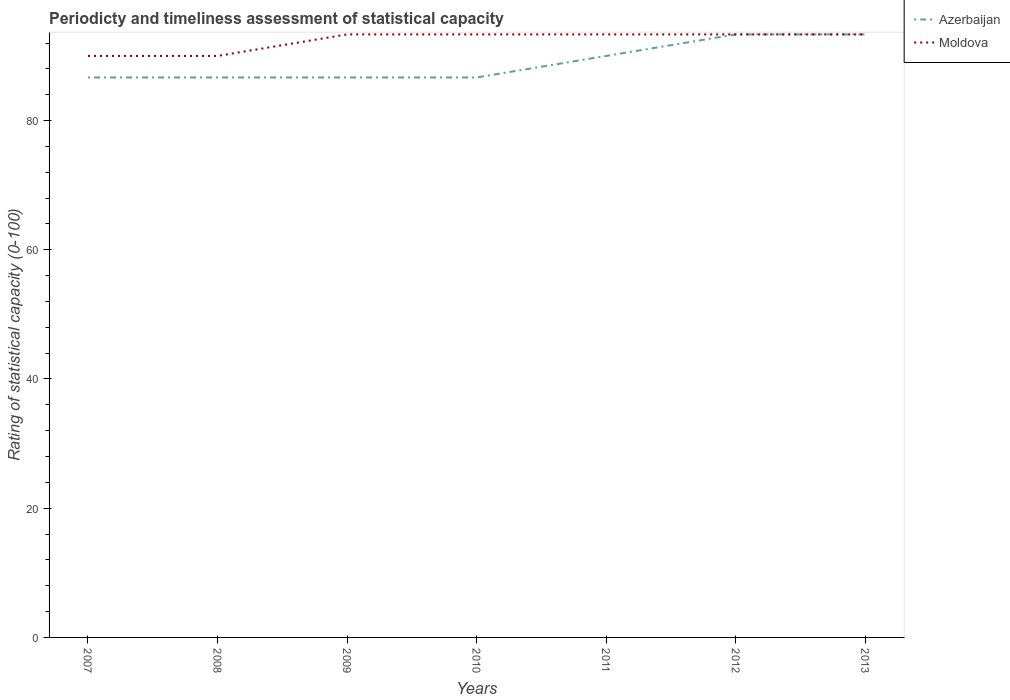Across all years, what is the maximum rating of statistical capacity in Azerbaijan?
Offer a very short reply. 86.67. In which year was the rating of statistical capacity in Azerbaijan maximum?
Ensure brevity in your answer.  2007. What is the total rating of statistical capacity in Moldova in the graph?
Offer a terse response. -3.33. What is the difference between the highest and the second highest rating of statistical capacity in Azerbaijan?
Offer a terse response. 6.67. How many lines are there?
Offer a terse response. 2. How many years are there in the graph?
Your answer should be very brief. 7. Are the values on the major ticks of Y-axis written in scientific E-notation?
Keep it short and to the point. No. Does the graph contain any zero values?
Keep it short and to the point. No. Where does the legend appear in the graph?
Provide a succinct answer. Top right. How many legend labels are there?
Ensure brevity in your answer.  2. What is the title of the graph?
Provide a succinct answer. Periodicty and timeliness assessment of statistical capacity. Does "Grenada" appear as one of the legend labels in the graph?
Give a very brief answer. No. What is the label or title of the Y-axis?
Ensure brevity in your answer.  Rating of statistical capacity (0-100). What is the Rating of statistical capacity (0-100) of Azerbaijan in 2007?
Offer a very short reply. 86.67. What is the Rating of statistical capacity (0-100) of Moldova in 2007?
Offer a terse response. 90. What is the Rating of statistical capacity (0-100) of Azerbaijan in 2008?
Offer a terse response. 86.67. What is the Rating of statistical capacity (0-100) of Azerbaijan in 2009?
Make the answer very short. 86.67. What is the Rating of statistical capacity (0-100) in Moldova in 2009?
Provide a succinct answer. 93.33. What is the Rating of statistical capacity (0-100) in Azerbaijan in 2010?
Offer a terse response. 86.67. What is the Rating of statistical capacity (0-100) of Moldova in 2010?
Ensure brevity in your answer.  93.33. What is the Rating of statistical capacity (0-100) of Azerbaijan in 2011?
Provide a short and direct response. 90. What is the Rating of statistical capacity (0-100) of Moldova in 2011?
Give a very brief answer. 93.33. What is the Rating of statistical capacity (0-100) in Azerbaijan in 2012?
Offer a terse response. 93.33. What is the Rating of statistical capacity (0-100) of Moldova in 2012?
Your answer should be very brief. 93.33. What is the Rating of statistical capacity (0-100) in Azerbaijan in 2013?
Offer a terse response. 93.33. What is the Rating of statistical capacity (0-100) in Moldova in 2013?
Ensure brevity in your answer.  93.33. Across all years, what is the maximum Rating of statistical capacity (0-100) of Azerbaijan?
Give a very brief answer. 93.33. Across all years, what is the maximum Rating of statistical capacity (0-100) of Moldova?
Your response must be concise. 93.33. Across all years, what is the minimum Rating of statistical capacity (0-100) in Azerbaijan?
Offer a very short reply. 86.67. What is the total Rating of statistical capacity (0-100) in Azerbaijan in the graph?
Give a very brief answer. 623.33. What is the total Rating of statistical capacity (0-100) in Moldova in the graph?
Make the answer very short. 646.67. What is the difference between the Rating of statistical capacity (0-100) of Azerbaijan in 2007 and that in 2011?
Provide a succinct answer. -3.33. What is the difference between the Rating of statistical capacity (0-100) of Moldova in 2007 and that in 2011?
Offer a terse response. -3.33. What is the difference between the Rating of statistical capacity (0-100) of Azerbaijan in 2007 and that in 2012?
Make the answer very short. -6.67. What is the difference between the Rating of statistical capacity (0-100) of Moldova in 2007 and that in 2012?
Give a very brief answer. -3.33. What is the difference between the Rating of statistical capacity (0-100) in Azerbaijan in 2007 and that in 2013?
Offer a very short reply. -6.67. What is the difference between the Rating of statistical capacity (0-100) of Moldova in 2007 and that in 2013?
Provide a short and direct response. -3.33. What is the difference between the Rating of statistical capacity (0-100) in Moldova in 2008 and that in 2009?
Your answer should be compact. -3.33. What is the difference between the Rating of statistical capacity (0-100) of Moldova in 2008 and that in 2011?
Offer a terse response. -3.33. What is the difference between the Rating of statistical capacity (0-100) of Azerbaijan in 2008 and that in 2012?
Your answer should be very brief. -6.67. What is the difference between the Rating of statistical capacity (0-100) in Moldova in 2008 and that in 2012?
Offer a very short reply. -3.33. What is the difference between the Rating of statistical capacity (0-100) of Azerbaijan in 2008 and that in 2013?
Ensure brevity in your answer.  -6.67. What is the difference between the Rating of statistical capacity (0-100) of Azerbaijan in 2009 and that in 2010?
Provide a short and direct response. 0. What is the difference between the Rating of statistical capacity (0-100) of Azerbaijan in 2009 and that in 2012?
Provide a succinct answer. -6.67. What is the difference between the Rating of statistical capacity (0-100) in Azerbaijan in 2009 and that in 2013?
Give a very brief answer. -6.67. What is the difference between the Rating of statistical capacity (0-100) of Azerbaijan in 2010 and that in 2012?
Offer a terse response. -6.67. What is the difference between the Rating of statistical capacity (0-100) of Moldova in 2010 and that in 2012?
Your answer should be very brief. 0. What is the difference between the Rating of statistical capacity (0-100) of Azerbaijan in 2010 and that in 2013?
Your response must be concise. -6.67. What is the difference between the Rating of statistical capacity (0-100) in Azerbaijan in 2011 and that in 2012?
Keep it short and to the point. -3.33. What is the difference between the Rating of statistical capacity (0-100) in Moldova in 2011 and that in 2013?
Your answer should be very brief. -0. What is the difference between the Rating of statistical capacity (0-100) in Moldova in 2012 and that in 2013?
Your answer should be compact. -0. What is the difference between the Rating of statistical capacity (0-100) in Azerbaijan in 2007 and the Rating of statistical capacity (0-100) in Moldova in 2009?
Your response must be concise. -6.67. What is the difference between the Rating of statistical capacity (0-100) in Azerbaijan in 2007 and the Rating of statistical capacity (0-100) in Moldova in 2010?
Provide a short and direct response. -6.67. What is the difference between the Rating of statistical capacity (0-100) in Azerbaijan in 2007 and the Rating of statistical capacity (0-100) in Moldova in 2011?
Keep it short and to the point. -6.67. What is the difference between the Rating of statistical capacity (0-100) in Azerbaijan in 2007 and the Rating of statistical capacity (0-100) in Moldova in 2012?
Provide a short and direct response. -6.67. What is the difference between the Rating of statistical capacity (0-100) of Azerbaijan in 2007 and the Rating of statistical capacity (0-100) of Moldova in 2013?
Provide a succinct answer. -6.67. What is the difference between the Rating of statistical capacity (0-100) of Azerbaijan in 2008 and the Rating of statistical capacity (0-100) of Moldova in 2009?
Provide a short and direct response. -6.67. What is the difference between the Rating of statistical capacity (0-100) of Azerbaijan in 2008 and the Rating of statistical capacity (0-100) of Moldova in 2010?
Your response must be concise. -6.67. What is the difference between the Rating of statistical capacity (0-100) of Azerbaijan in 2008 and the Rating of statistical capacity (0-100) of Moldova in 2011?
Your answer should be compact. -6.67. What is the difference between the Rating of statistical capacity (0-100) of Azerbaijan in 2008 and the Rating of statistical capacity (0-100) of Moldova in 2012?
Offer a terse response. -6.67. What is the difference between the Rating of statistical capacity (0-100) of Azerbaijan in 2008 and the Rating of statistical capacity (0-100) of Moldova in 2013?
Provide a short and direct response. -6.67. What is the difference between the Rating of statistical capacity (0-100) in Azerbaijan in 2009 and the Rating of statistical capacity (0-100) in Moldova in 2010?
Keep it short and to the point. -6.67. What is the difference between the Rating of statistical capacity (0-100) in Azerbaijan in 2009 and the Rating of statistical capacity (0-100) in Moldova in 2011?
Make the answer very short. -6.67. What is the difference between the Rating of statistical capacity (0-100) in Azerbaijan in 2009 and the Rating of statistical capacity (0-100) in Moldova in 2012?
Your answer should be compact. -6.67. What is the difference between the Rating of statistical capacity (0-100) of Azerbaijan in 2009 and the Rating of statistical capacity (0-100) of Moldova in 2013?
Provide a succinct answer. -6.67. What is the difference between the Rating of statistical capacity (0-100) of Azerbaijan in 2010 and the Rating of statistical capacity (0-100) of Moldova in 2011?
Make the answer very short. -6.67. What is the difference between the Rating of statistical capacity (0-100) of Azerbaijan in 2010 and the Rating of statistical capacity (0-100) of Moldova in 2012?
Your answer should be very brief. -6.67. What is the difference between the Rating of statistical capacity (0-100) in Azerbaijan in 2010 and the Rating of statistical capacity (0-100) in Moldova in 2013?
Your answer should be compact. -6.67. What is the difference between the Rating of statistical capacity (0-100) of Azerbaijan in 2011 and the Rating of statistical capacity (0-100) of Moldova in 2013?
Your response must be concise. -3.33. What is the average Rating of statistical capacity (0-100) in Azerbaijan per year?
Offer a terse response. 89.05. What is the average Rating of statistical capacity (0-100) in Moldova per year?
Your answer should be very brief. 92.38. In the year 2008, what is the difference between the Rating of statistical capacity (0-100) of Azerbaijan and Rating of statistical capacity (0-100) of Moldova?
Provide a succinct answer. -3.33. In the year 2009, what is the difference between the Rating of statistical capacity (0-100) of Azerbaijan and Rating of statistical capacity (0-100) of Moldova?
Ensure brevity in your answer.  -6.67. In the year 2010, what is the difference between the Rating of statistical capacity (0-100) of Azerbaijan and Rating of statistical capacity (0-100) of Moldova?
Your answer should be very brief. -6.67. In the year 2011, what is the difference between the Rating of statistical capacity (0-100) of Azerbaijan and Rating of statistical capacity (0-100) of Moldova?
Your answer should be compact. -3.33. What is the ratio of the Rating of statistical capacity (0-100) in Azerbaijan in 2007 to that in 2008?
Provide a succinct answer. 1. What is the ratio of the Rating of statistical capacity (0-100) in Azerbaijan in 2007 to that in 2010?
Keep it short and to the point. 1. What is the ratio of the Rating of statistical capacity (0-100) in Azerbaijan in 2007 to that in 2011?
Provide a succinct answer. 0.96. What is the ratio of the Rating of statistical capacity (0-100) of Moldova in 2007 to that in 2012?
Your answer should be very brief. 0.96. What is the ratio of the Rating of statistical capacity (0-100) of Moldova in 2007 to that in 2013?
Your answer should be compact. 0.96. What is the ratio of the Rating of statistical capacity (0-100) in Azerbaijan in 2008 to that in 2009?
Offer a very short reply. 1. What is the ratio of the Rating of statistical capacity (0-100) in Moldova in 2008 to that in 2010?
Provide a succinct answer. 0.96. What is the ratio of the Rating of statistical capacity (0-100) in Azerbaijan in 2008 to that in 2012?
Provide a succinct answer. 0.93. What is the ratio of the Rating of statistical capacity (0-100) of Moldova in 2008 to that in 2012?
Keep it short and to the point. 0.96. What is the ratio of the Rating of statistical capacity (0-100) in Azerbaijan in 2008 to that in 2013?
Provide a short and direct response. 0.93. What is the ratio of the Rating of statistical capacity (0-100) of Azerbaijan in 2009 to that in 2010?
Provide a succinct answer. 1. What is the ratio of the Rating of statistical capacity (0-100) in Moldova in 2009 to that in 2013?
Provide a short and direct response. 1. What is the ratio of the Rating of statistical capacity (0-100) of Azerbaijan in 2010 to that in 2011?
Keep it short and to the point. 0.96. What is the ratio of the Rating of statistical capacity (0-100) of Moldova in 2010 to that in 2012?
Ensure brevity in your answer.  1. What is the ratio of the Rating of statistical capacity (0-100) in Azerbaijan in 2011 to that in 2012?
Give a very brief answer. 0.96. What is the ratio of the Rating of statistical capacity (0-100) of Moldova in 2011 to that in 2013?
Offer a terse response. 1. What is the ratio of the Rating of statistical capacity (0-100) of Moldova in 2012 to that in 2013?
Your response must be concise. 1. What is the difference between the highest and the second highest Rating of statistical capacity (0-100) in Moldova?
Make the answer very short. 0. 